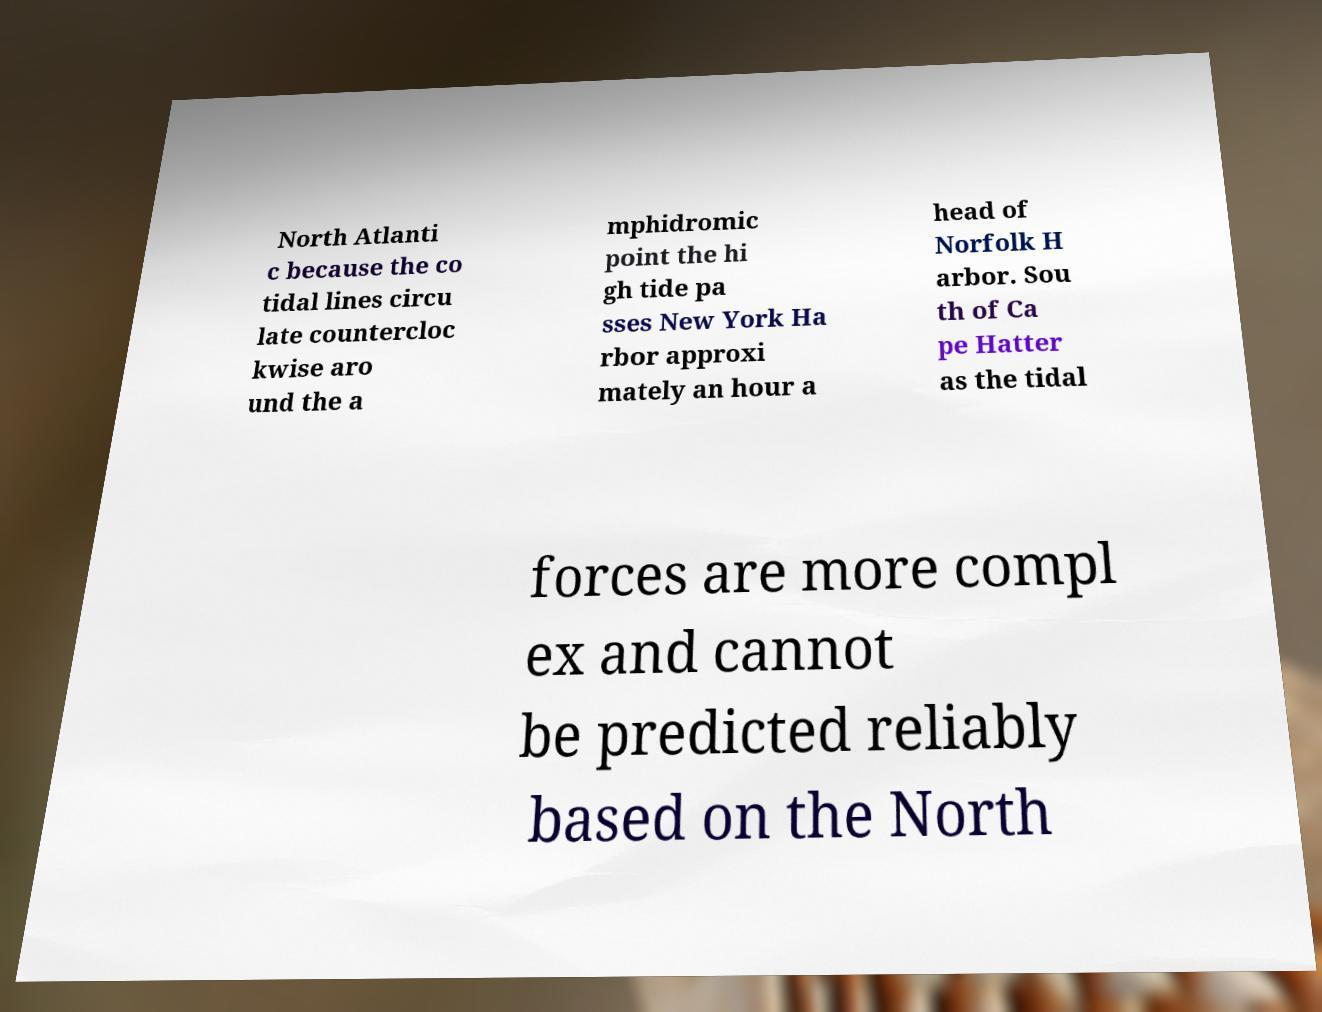For documentation purposes, I need the text within this image transcribed. Could you provide that? North Atlanti c because the co tidal lines circu late countercloc kwise aro und the a mphidromic point the hi gh tide pa sses New York Ha rbor approxi mately an hour a head of Norfolk H arbor. Sou th of Ca pe Hatter as the tidal forces are more compl ex and cannot be predicted reliably based on the North 